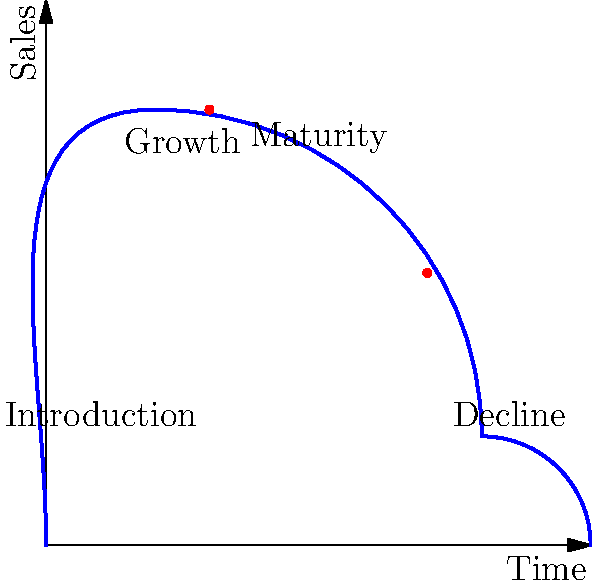In the product lifecycle curve shown above, which stage is represented by the point (3,8), and what strategic decision should an entrepreneur consider at the point (7,5)? To answer this question, let's analyze the product lifecycle curve and the marked points:

1. The product lifecycle curve typically consists of four stages: Introduction, Growth, Maturity, and Decline.

2. Point (3,8):
   - This point is located near the peak of the curve.
   - It's in the area where sales are rapidly increasing.
   - This corresponds to the Growth stage of the product lifecycle.

3. Point (7,5):
   - This point is located on the descending part of the curve.
   - It's in the area where sales are starting to decrease.
   - This corresponds to the late Maturity or early Decline stage.

4. Strategic decision at point (7,5):
   - As the product is entering the Decline stage, an entrepreneur should consider product revitalization or diversification.
   - This could involve:
     a) Introducing new features or improvements to extend the product's life.
     b) Exploring new markets or applications for the existing product.
     c) Developing new products to replace the declining one.
   - The goal is to either reinvigorate sales or prepare for the product's eventual phase-out.

Therefore, the point (3,8) represents the Growth stage, and at point (7,5), an entrepreneur should consider product revitalization or diversification strategies.
Answer: Growth stage; Consider product revitalization or diversification 